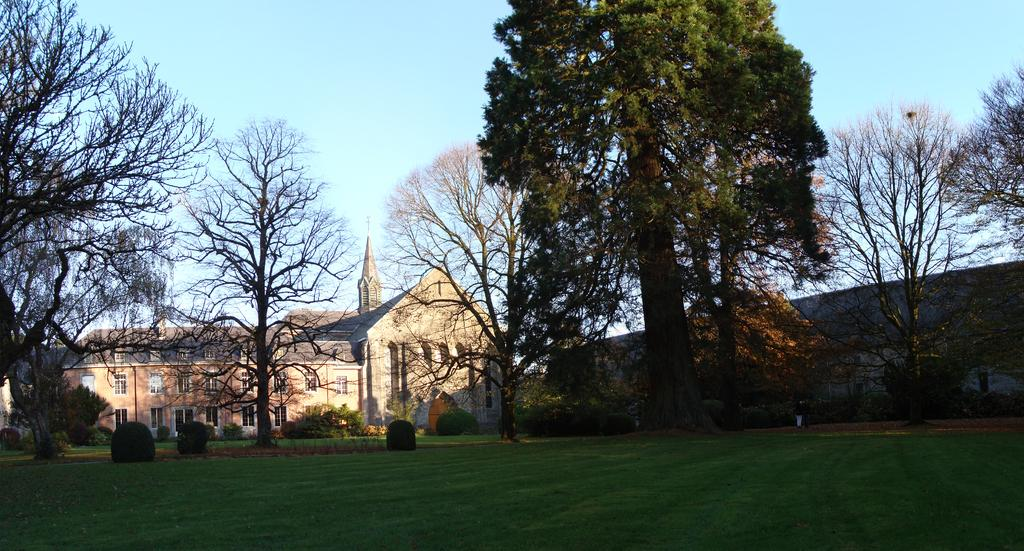What type of vegetation can be seen in the image? There are plants and trees in the image. Where are the plants and trees located? The plants and trees are on a grassland. What structures can be seen on the sides of the image? There is a building on the left side of the image and a wall on the right side of the image. What is visible at the top of the image? The sky is visible at the top of the image. Can you tell me how many bees are buzzing around the pot in the image? There is no pot or bees present in the image; it features plants, trees, and a grassland. What type of exchange is taking place between the plants and the building in the image? There is no exchange between the plants and the building in the image; they are separate entities in the scene. 